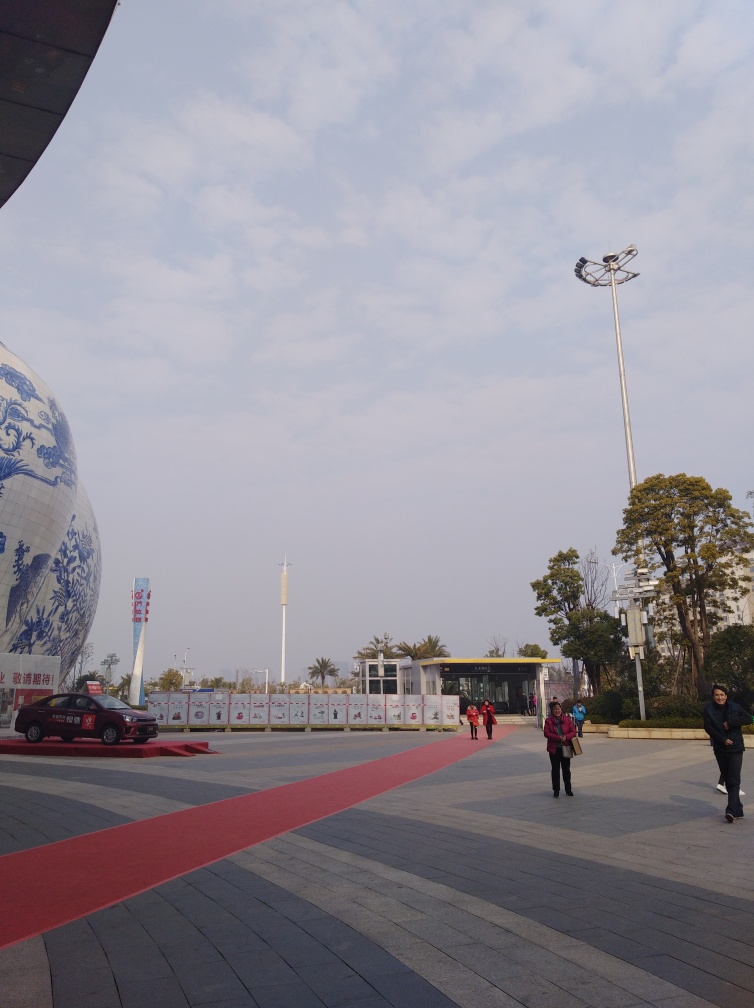What are the colors like in the image? The image displays a predominance of soft hues with a wide-open sky in light blue scattered with white clouds. The large sphere to the left is enveloped in tones of white and blue, featuring traditional patterns. The pavement combines elements of gray and red, providing a sense of depth with the red carpet acting as a leading line. Surrounding greenery adds subtle touches of natural green, contrasting with the urban setting. 